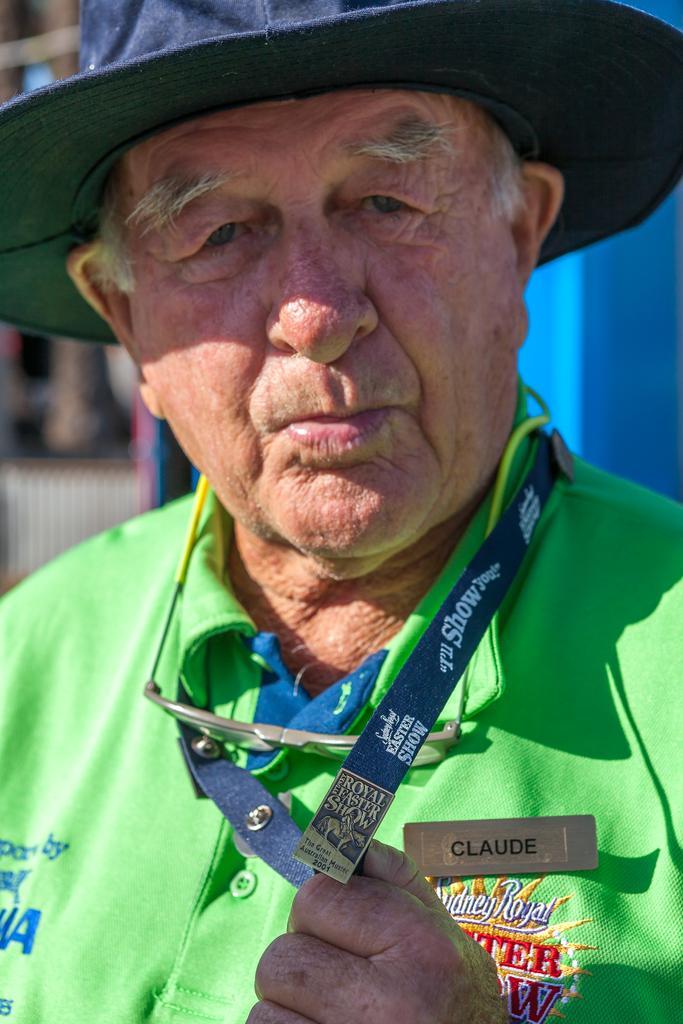Describe this image in one or two sentences. In this picture I can see there is a old man standing and he is wearing a green shirt and he is wearing a ID card, a hat, glasses and he has a badge. In the backdrop there is a blue color object and the backdrop is blurred. 